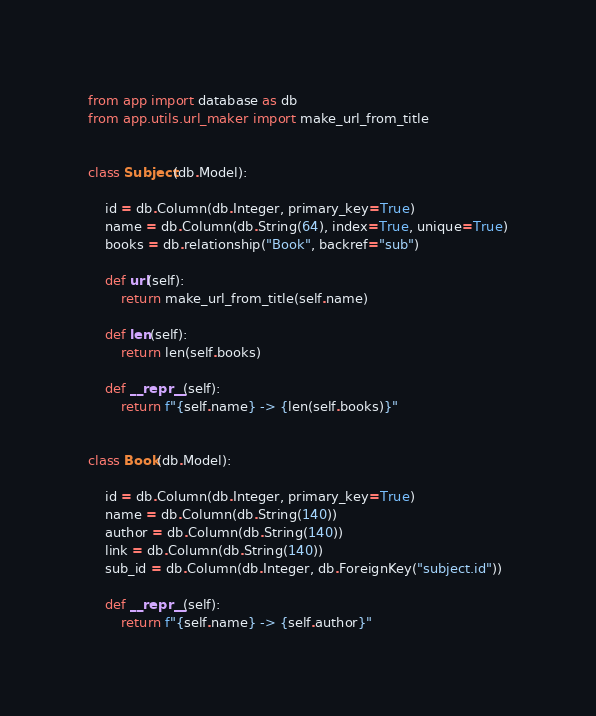Convert code to text. <code><loc_0><loc_0><loc_500><loc_500><_Python_>from app import database as db
from app.utils.url_maker import make_url_from_title


class Subject(db.Model):

    id = db.Column(db.Integer, primary_key=True)
    name = db.Column(db.String(64), index=True, unique=True)
    books = db.relationship("Book", backref="sub")

    def url(self):
        return make_url_from_title(self.name)

    def len(self):
        return len(self.books)

    def __repr__(self):
        return f"{self.name} -> {len(self.books)}"


class Book(db.Model):

    id = db.Column(db.Integer, primary_key=True)
    name = db.Column(db.String(140))
    author = db.Column(db.String(140))
    link = db.Column(db.String(140))
    sub_id = db.Column(db.Integer, db.ForeignKey("subject.id"))

    def __repr__(self):
        return f"{self.name} -> {self.author}"
</code> 